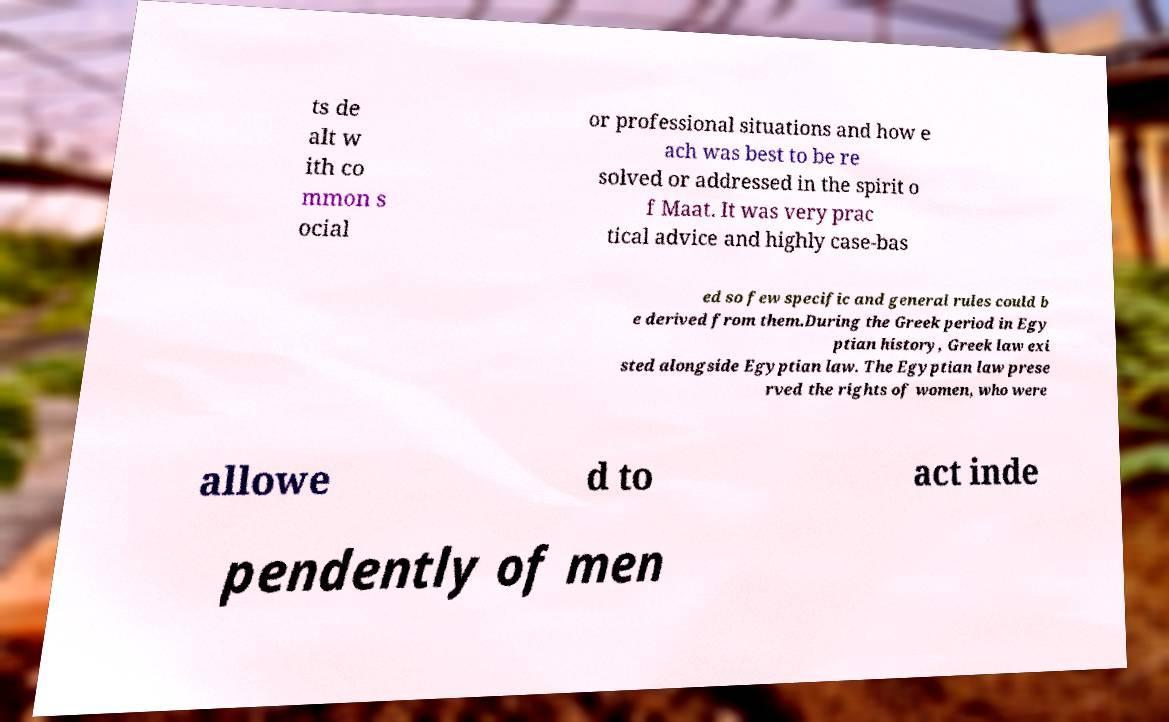Can you accurately transcribe the text from the provided image for me? ts de alt w ith co mmon s ocial or professional situations and how e ach was best to be re solved or addressed in the spirit o f Maat. It was very prac tical advice and highly case-bas ed so few specific and general rules could b e derived from them.During the Greek period in Egy ptian history, Greek law exi sted alongside Egyptian law. The Egyptian law prese rved the rights of women, who were allowe d to act inde pendently of men 